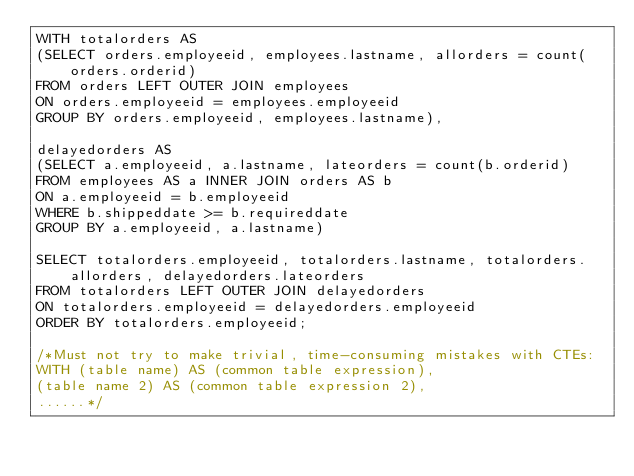<code> <loc_0><loc_0><loc_500><loc_500><_SQL_>WITH totalorders AS
(SELECT orders.employeeid, employees.lastname, allorders = count(orders.orderid)
FROM orders LEFT OUTER JOIN employees
ON orders.employeeid = employees.employeeid
GROUP BY orders.employeeid, employees.lastname),

delayedorders AS
(SELECT a.employeeid, a.lastname, lateorders = count(b.orderid)
FROM employees AS a INNER JOIN orders AS b
ON a.employeeid = b.employeeid
WHERE b.shippeddate >= b.requireddate
GROUP BY a.employeeid, a.lastname)

SELECT totalorders.employeeid, totalorders.lastname, totalorders.allorders, delayedorders.lateorders
FROM totalorders LEFT OUTER JOIN delayedorders
ON totalorders.employeeid = delayedorders.employeeid
ORDER BY totalorders.employeeid;

/*Must not try to make trivial, time-consuming mistakes with CTEs:
WITH (table name) AS (common table expression),
(table name 2) AS (common table expression 2),
......*/</code> 